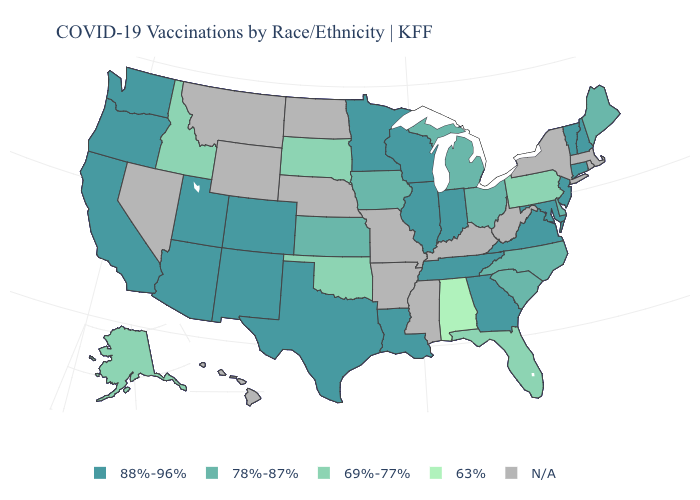Which states have the highest value in the USA?
Give a very brief answer. Arizona, California, Colorado, Connecticut, Georgia, Illinois, Indiana, Louisiana, Maryland, Minnesota, New Hampshire, New Jersey, New Mexico, Oregon, Tennessee, Texas, Utah, Vermont, Virginia, Washington, Wisconsin. Which states have the lowest value in the USA?
Answer briefly. Alabama. What is the value of Mississippi?
Quick response, please. N/A. What is the highest value in the MidWest ?
Keep it brief. 88%-96%. Among the states that border Alabama , which have the lowest value?
Quick response, please. Florida. Does the map have missing data?
Concise answer only. Yes. Does New Hampshire have the highest value in the USA?
Quick response, please. Yes. Name the states that have a value in the range 63%?
Quick response, please. Alabama. Which states have the lowest value in the MidWest?
Give a very brief answer. South Dakota. Does Idaho have the highest value in the West?
Keep it brief. No. 